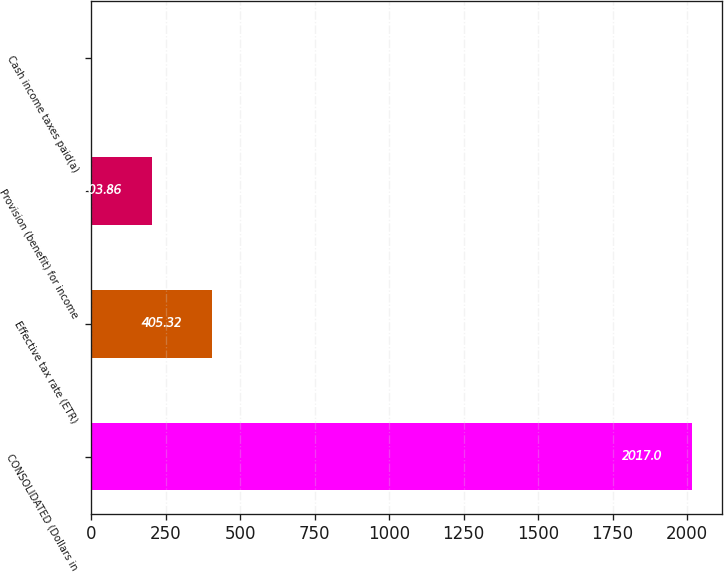<chart> <loc_0><loc_0><loc_500><loc_500><bar_chart><fcel>CONSOLIDATED (Dollars in<fcel>Effective tax rate (ETR)<fcel>Provision (benefit) for income<fcel>Cash income taxes paid(a)<nl><fcel>2017<fcel>405.32<fcel>203.86<fcel>2.4<nl></chart> 